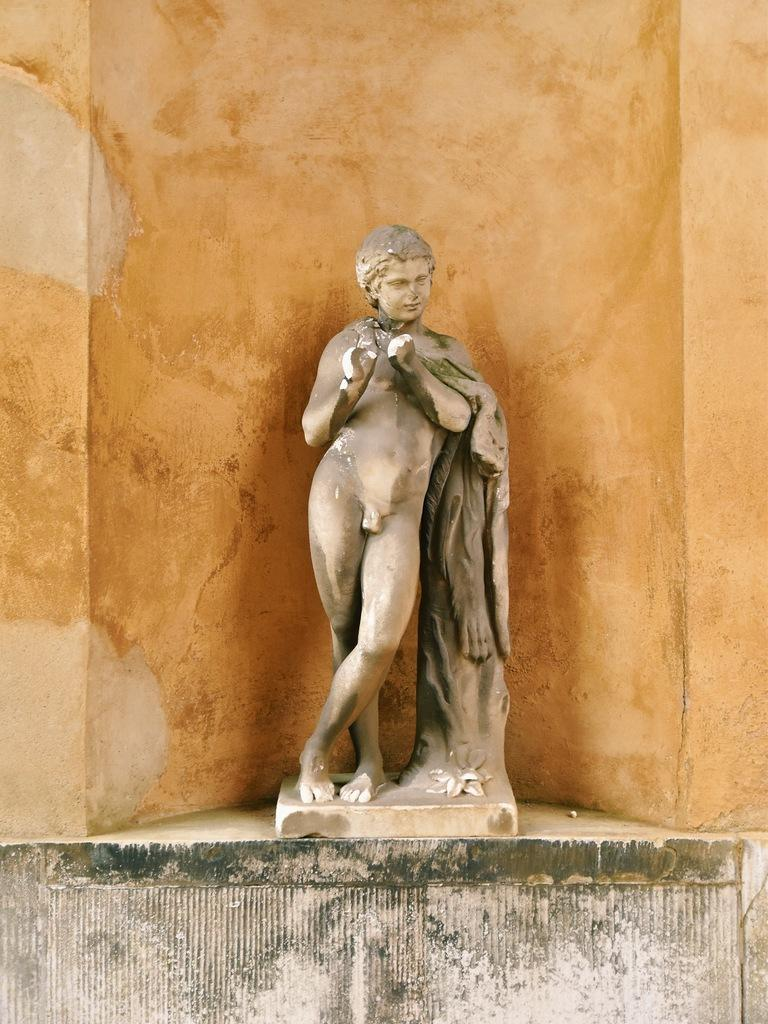What is depicted on the wall in the image? There is a sculpture of a person on the wall. What is the color of the background behind the sculpture? The background of the sculpture has an orange color. Reasoning: Let's think step by identifying the main subject in the image, which is the sculpture of a person on the wall. Then, we expand the conversation to include the color of the background, which is orange. Each question is designed to elicit a specific detail about the image that is known from the provided facts. Absurd Question/Answer: What type of mint is used to decorate the collar of the person in the sculpture? There is no mention of mint or a collar in the image, as the sculpture is of a person and not a living being with clothing. Is there an actor standing next to the sculpture in the image? There is no actor present in the image; it only features a sculpture of a person on the wall. 